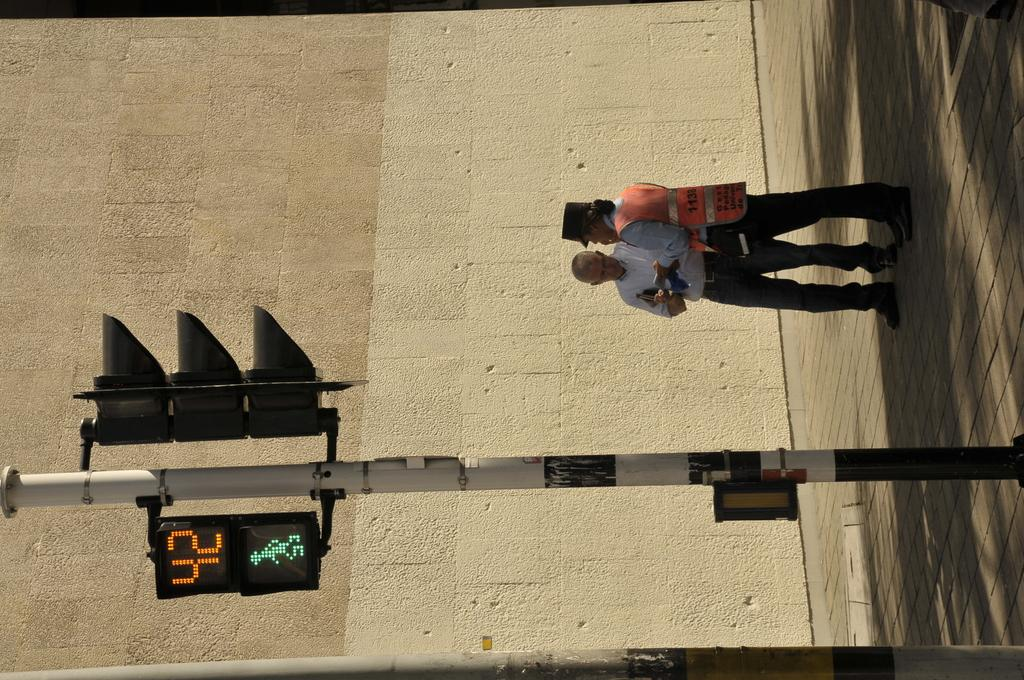<image>
Give a short and clear explanation of the subsequent image. Two people stand next to a street light that has the number 42 on it. 